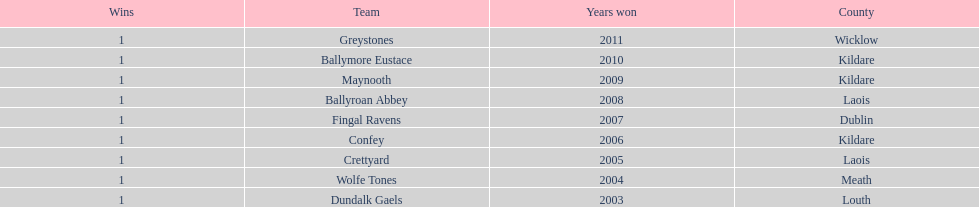What is the total of wins on the chart 9. 